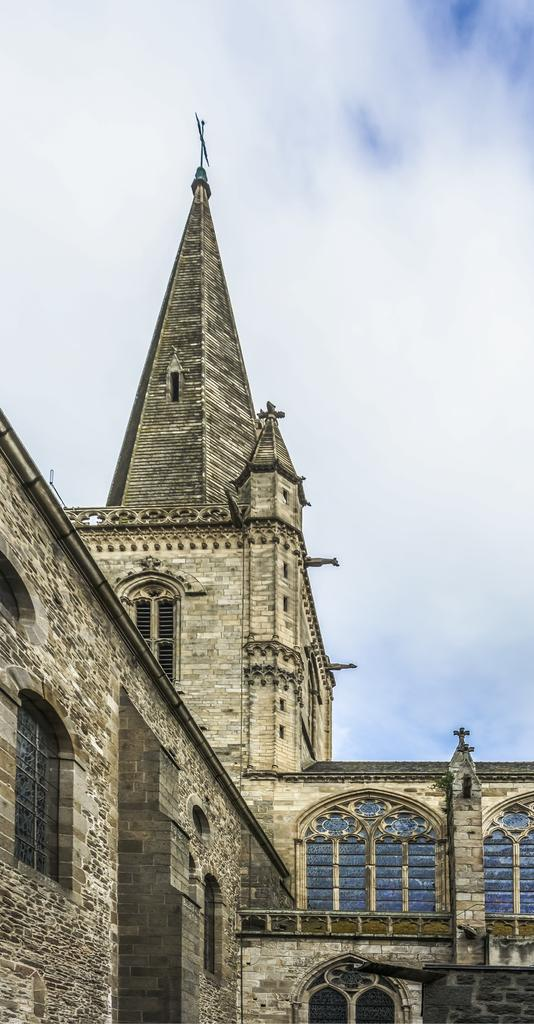What type of structure is present in the image? There is a building in the image. What can be seen in the background of the image? The sky is visible in the image. How many icicles are hanging from the building in the image? There are no icicles present in the image. What type of animals can be seen roaming around the building in the image? There are no animals, such as chickens, present in the image. 